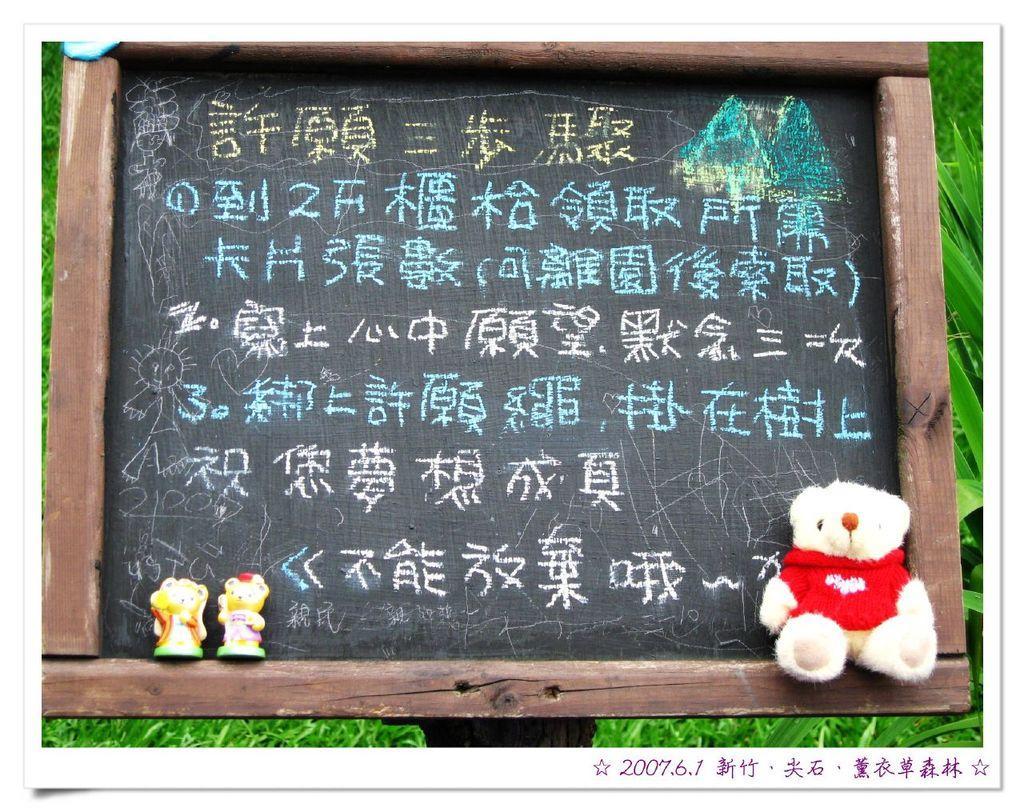Please provide a concise description of this image. In this image there is a black board and I can see some text on that and also a teddy bear and two toys are placed on this board. In the background there are some plants. 